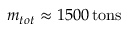Convert formula to latex. <formula><loc_0><loc_0><loc_500><loc_500>m _ { t o t } \approx 1 5 0 0 \, { t o n s }</formula> 